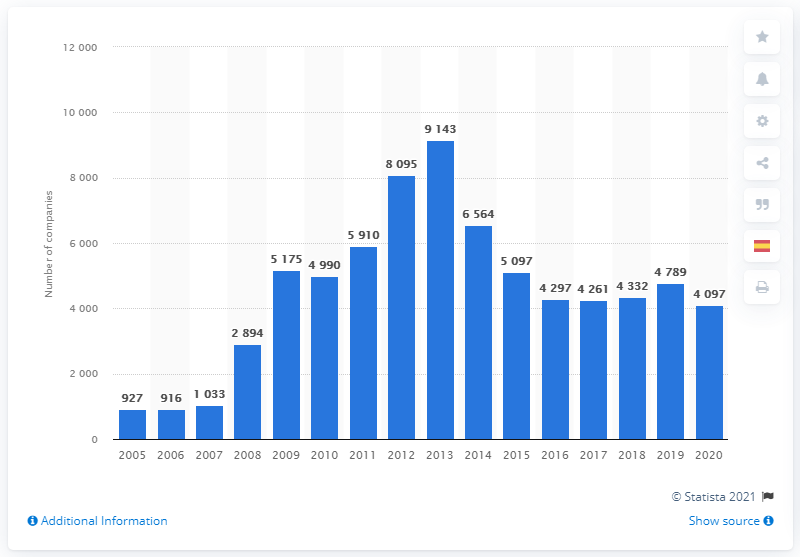Specify some key components in this picture. In 2020, a total of 4097 companies in Spain were declared bankrupt. The number of companies declaring bankruptcy began decreasing in 2013. 